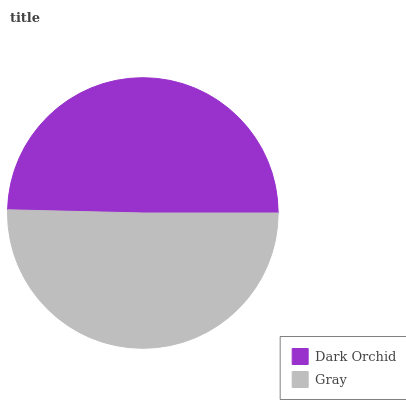Is Dark Orchid the minimum?
Answer yes or no. Yes. Is Gray the maximum?
Answer yes or no. Yes. Is Gray the minimum?
Answer yes or no. No. Is Gray greater than Dark Orchid?
Answer yes or no. Yes. Is Dark Orchid less than Gray?
Answer yes or no. Yes. Is Dark Orchid greater than Gray?
Answer yes or no. No. Is Gray less than Dark Orchid?
Answer yes or no. No. Is Gray the high median?
Answer yes or no. Yes. Is Dark Orchid the low median?
Answer yes or no. Yes. Is Dark Orchid the high median?
Answer yes or no. No. Is Gray the low median?
Answer yes or no. No. 